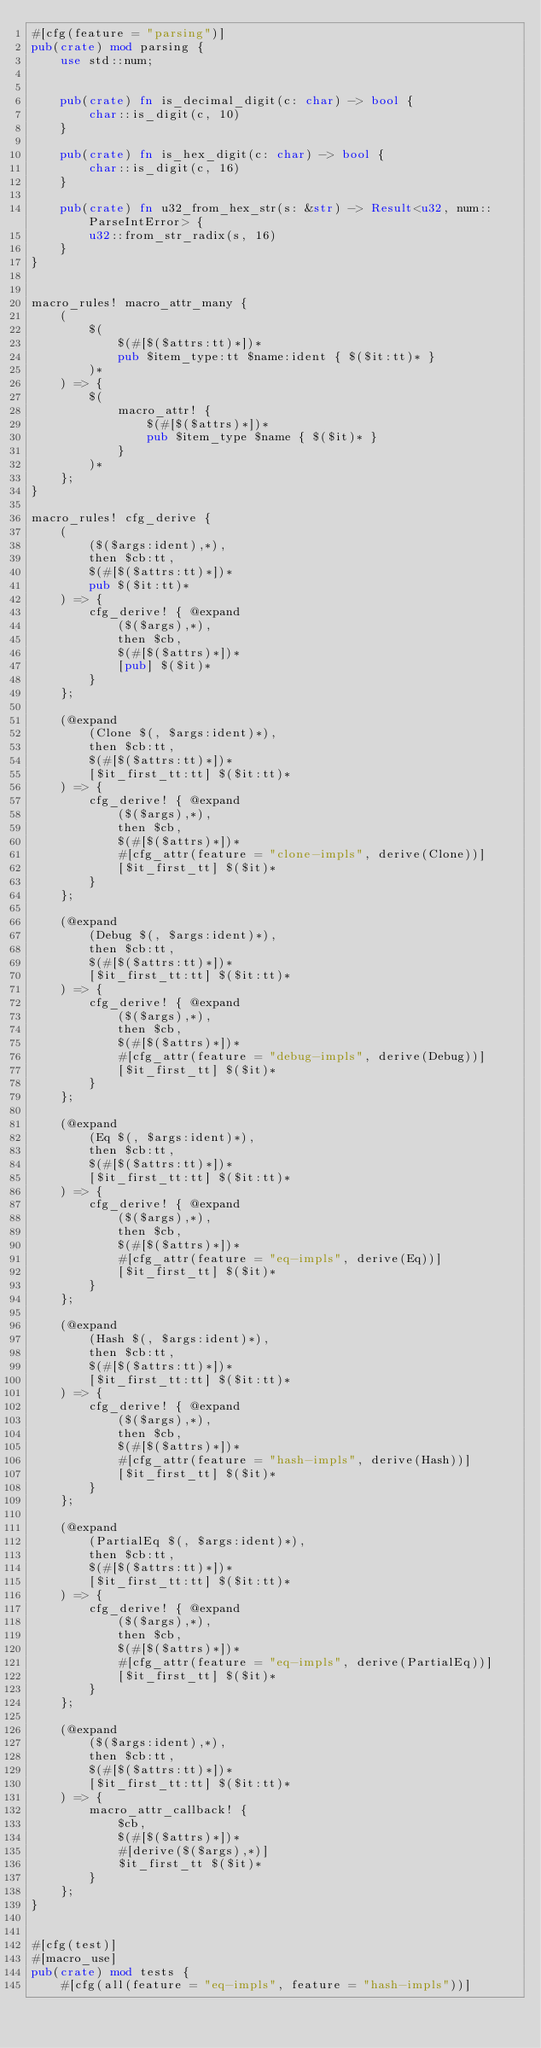<code> <loc_0><loc_0><loc_500><loc_500><_Rust_>#[cfg(feature = "parsing")]
pub(crate) mod parsing {
    use std::num;


    pub(crate) fn is_decimal_digit(c: char) -> bool {
        char::is_digit(c, 10)
    }

    pub(crate) fn is_hex_digit(c: char) -> bool {
        char::is_digit(c, 16)
    }

    pub(crate) fn u32_from_hex_str(s: &str) -> Result<u32, num::ParseIntError> {
        u32::from_str_radix(s, 16)
    }
}


macro_rules! macro_attr_many {
    (
        $(
            $(#[$($attrs:tt)*])*
            pub $item_type:tt $name:ident { $($it:tt)* }
        )*
    ) => {
        $(
            macro_attr! {
                $(#[$($attrs)*])*
                pub $item_type $name { $($it)* }
            }
        )*
    };
}

macro_rules! cfg_derive {
    (
        ($($args:ident),*),
        then $cb:tt,
        $(#[$($attrs:tt)*])*
        pub $($it:tt)*
    ) => {
        cfg_derive! { @expand
            ($($args),*),
            then $cb,
            $(#[$($attrs)*])*
            [pub] $($it)*
        }
    };

    (@expand
        (Clone $(, $args:ident)*),
        then $cb:tt,
        $(#[$($attrs:tt)*])*
        [$it_first_tt:tt] $($it:tt)*
    ) => {
        cfg_derive! { @expand
            ($($args),*),
            then $cb,
            $(#[$($attrs)*])*
            #[cfg_attr(feature = "clone-impls", derive(Clone))]
            [$it_first_tt] $($it)*
        }
    };

    (@expand
        (Debug $(, $args:ident)*),
        then $cb:tt,
        $(#[$($attrs:tt)*])*
        [$it_first_tt:tt] $($it:tt)*
    ) => {
        cfg_derive! { @expand
            ($($args),*),
            then $cb,
            $(#[$($attrs)*])*
            #[cfg_attr(feature = "debug-impls", derive(Debug))]
            [$it_first_tt] $($it)*
        }
    };

    (@expand
        (Eq $(, $args:ident)*),
        then $cb:tt,
        $(#[$($attrs:tt)*])*
        [$it_first_tt:tt] $($it:tt)*
    ) => {
        cfg_derive! { @expand
            ($($args),*),
            then $cb,
            $(#[$($attrs)*])*
            #[cfg_attr(feature = "eq-impls", derive(Eq))]
            [$it_first_tt] $($it)*
        }
    };

    (@expand
        (Hash $(, $args:ident)*),
        then $cb:tt,
        $(#[$($attrs:tt)*])*
        [$it_first_tt:tt] $($it:tt)*
    ) => {
        cfg_derive! { @expand
            ($($args),*),
            then $cb,
            $(#[$($attrs)*])*
            #[cfg_attr(feature = "hash-impls", derive(Hash))]
            [$it_first_tt] $($it)*
        }
    };

    (@expand
        (PartialEq $(, $args:ident)*),
        then $cb:tt,
        $(#[$($attrs:tt)*])*
        [$it_first_tt:tt] $($it:tt)*
    ) => {
        cfg_derive! { @expand
            ($($args),*),
            then $cb,
            $(#[$($attrs)*])*
            #[cfg_attr(feature = "eq-impls", derive(PartialEq))]
            [$it_first_tt] $($it)*
        }
    };

    (@expand
        ($($args:ident),*),
        then $cb:tt,
        $(#[$($attrs:tt)*])*
        [$it_first_tt:tt] $($it:tt)*
    ) => {
        macro_attr_callback! {
            $cb,
            $(#[$($attrs)*])*
            #[derive($($args),*)]
            $it_first_tt $($it)*
        }
    };
}


#[cfg(test)]
#[macro_use]
pub(crate) mod tests {
    #[cfg(all(feature = "eq-impls", feature = "hash-impls"))]</code> 